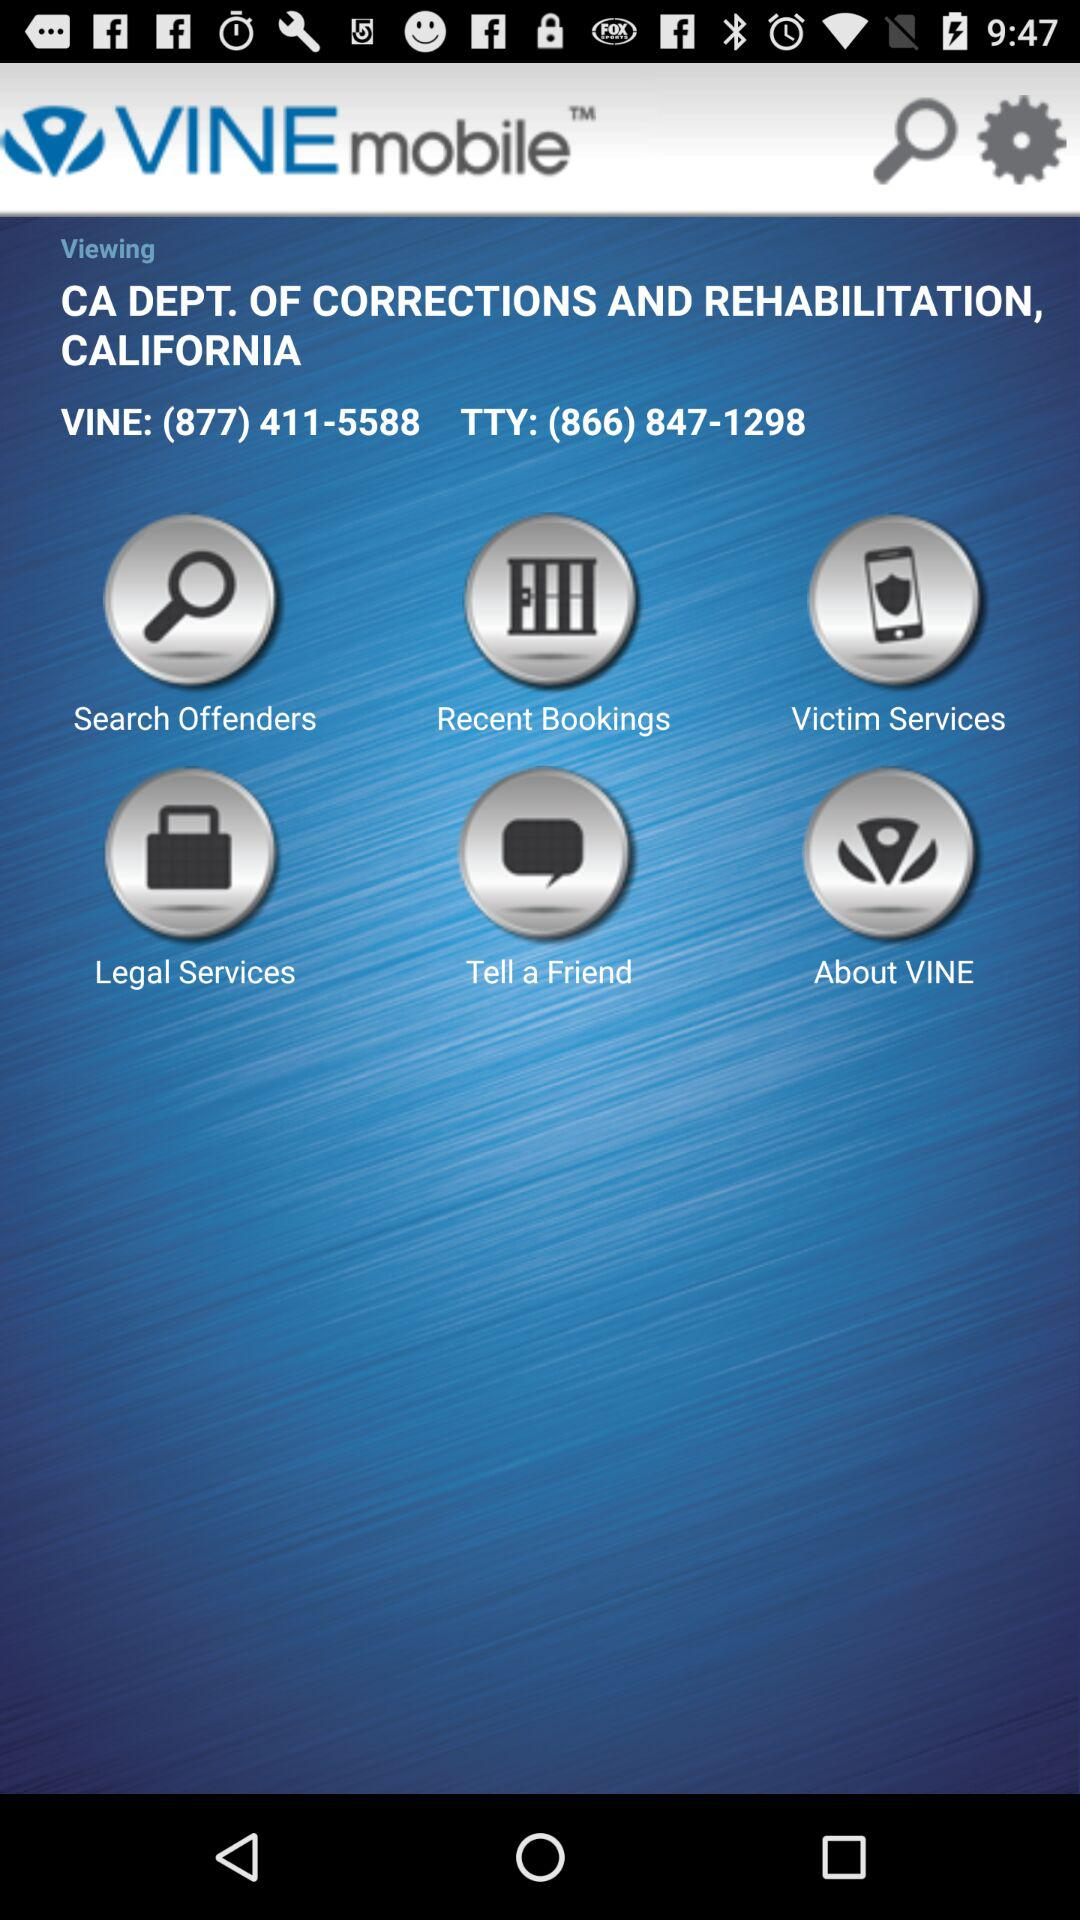What is the name of the application? The name of the application is "VINE mobile". 